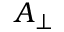Convert formula to latex. <formula><loc_0><loc_0><loc_500><loc_500>{ A } _ { \perp }</formula> 